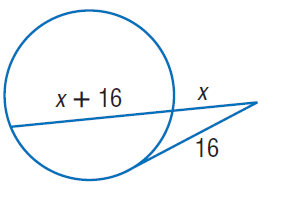Answer the mathemtical geometry problem and directly provide the correct option letter.
Question: Find x. Round to the nearest tenth if necessary. Assume that segments that appear to be tangent are tangent.
Choices: A: 8 B: 16 C: 24 D: 32 A 